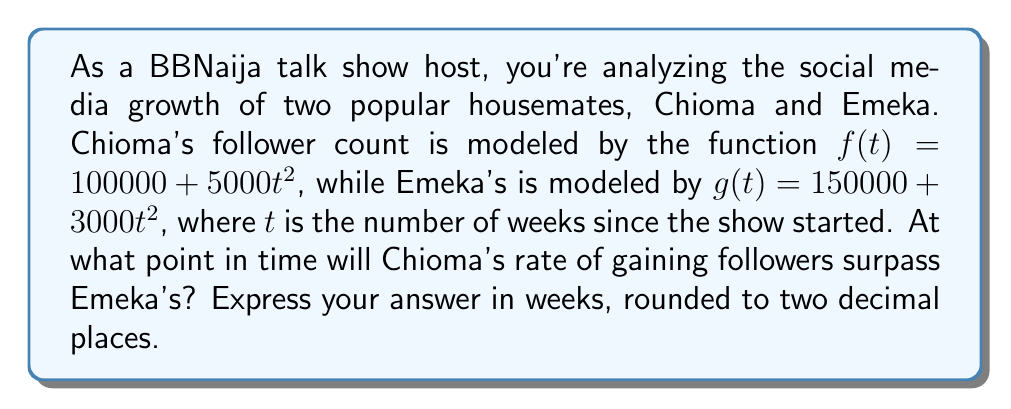Can you answer this question? To solve this problem, we need to follow these steps:

1) First, we need to find the rate of change for each housemate's follower count. This is done by taking the derivative of each function with respect to time.

   For Chioma: $f'(t) = 10000t$
   For Emeka: $g'(t) = 6000t$

2) Chioma's rate will surpass Emeka's when $f'(t) > g'(t)$. To find the exact point, we set them equal:

   $10000t = 6000t$

3) Subtract $6000t$ from both sides:

   $4000t = 0$

4) Divide both sides by 4000:

   $t = 0$

5) This result means that Chioma's rate of gaining followers is always higher than Emeka's after $t = 0$.

6) To verify, let's check the rates at $t = 1$ week:

   Chioma's rate at 1 week: $f'(1) = 10000$ followers/week
   Emeka's rate at 1 week: $g'(1) = 6000$ followers/week

Indeed, Chioma's rate is higher.

Therefore, Chioma's rate of gaining followers surpasses Emeka's immediately after the show starts.
Answer: 0.00 weeks 